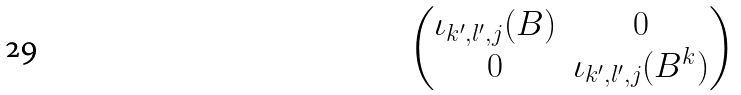<formula> <loc_0><loc_0><loc_500><loc_500>\begin{pmatrix} \iota _ { k ^ { \prime } , l ^ { \prime } , j } ( B ) & 0 \\ 0 & \iota _ { k ^ { \prime } , l ^ { \prime } , j } ( B ^ { k } ) \end{pmatrix}</formula> 